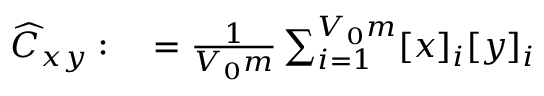<formula> <loc_0><loc_0><loc_500><loc_500>\begin{array} { r l } { \widehat { C } _ { x y } \colon } & = \frac { 1 } { V _ { 0 } m } \sum _ { i = 1 } ^ { V _ { 0 } m } [ x ] _ { i } [ y ] _ { i } } \end{array}</formula> 